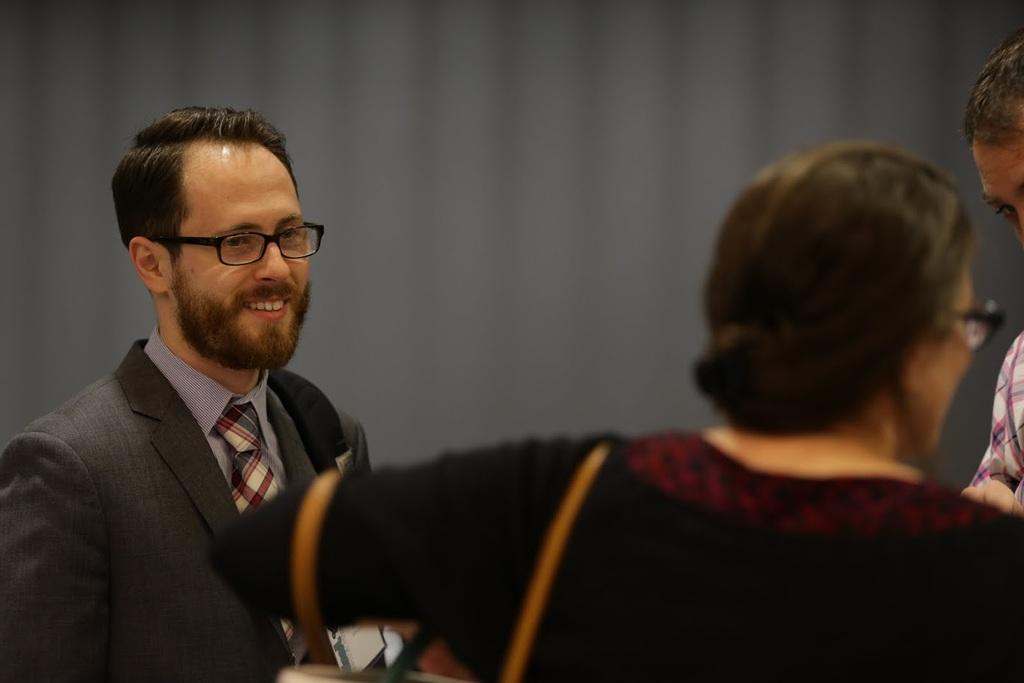What is happening in the image? There are people standing in the image. Where are the people located in the image? The people are in the middle of the image. What can be seen in the background of the image? There is a wall visible in the image. What type of pollution can be seen in the image? There is no pollution visible in the image. Is there a band playing in the image? There is no band present in the image. 